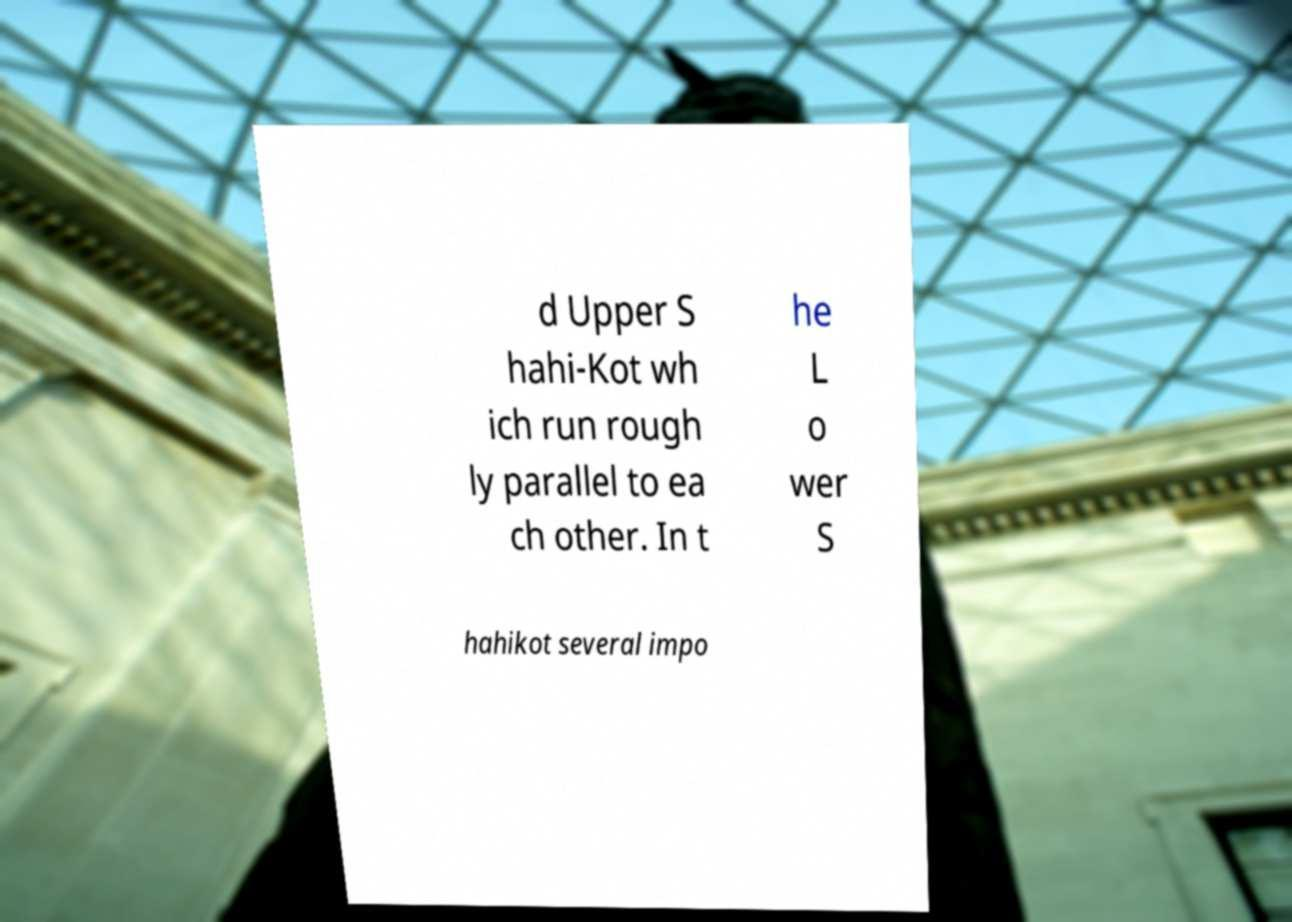There's text embedded in this image that I need extracted. Can you transcribe it verbatim? d Upper S hahi-Kot wh ich run rough ly parallel to ea ch other. In t he L o wer S hahikot several impo 